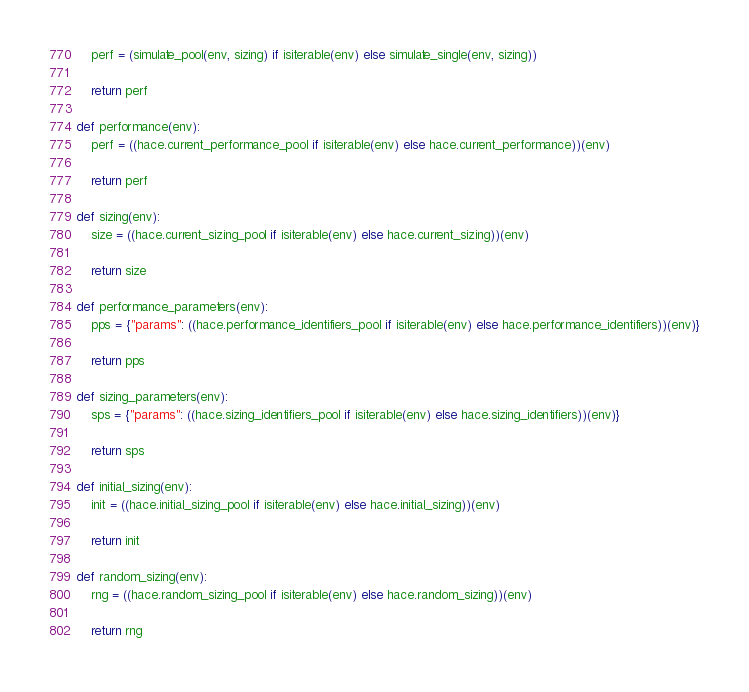<code> <loc_0><loc_0><loc_500><loc_500><_Python_>    perf = (simulate_pool(env, sizing) if isiterable(env) else simulate_single(env, sizing))

    return perf

def performance(env):
    perf = ((hace.current_performance_pool if isiterable(env) else hace.current_performance))(env)

    return perf

def sizing(env):
    size = ((hace.current_sizing_pool if isiterable(env) else hace.current_sizing))(env)

    return size

def performance_parameters(env):
    pps = {"params": ((hace.performance_identifiers_pool if isiterable(env) else hace.performance_identifiers))(env)}

    return pps

def sizing_parameters(env):
    sps = {"params": ((hace.sizing_identifiers_pool if isiterable(env) else hace.sizing_identifiers))(env)}

    return sps

def initial_sizing(env):
    init = ((hace.initial_sizing_pool if isiterable(env) else hace.initial_sizing))(env)

    return init

def random_sizing(env):
    rng = ((hace.random_sizing_pool if isiterable(env) else hace.random_sizing))(env)

    return rng
</code> 